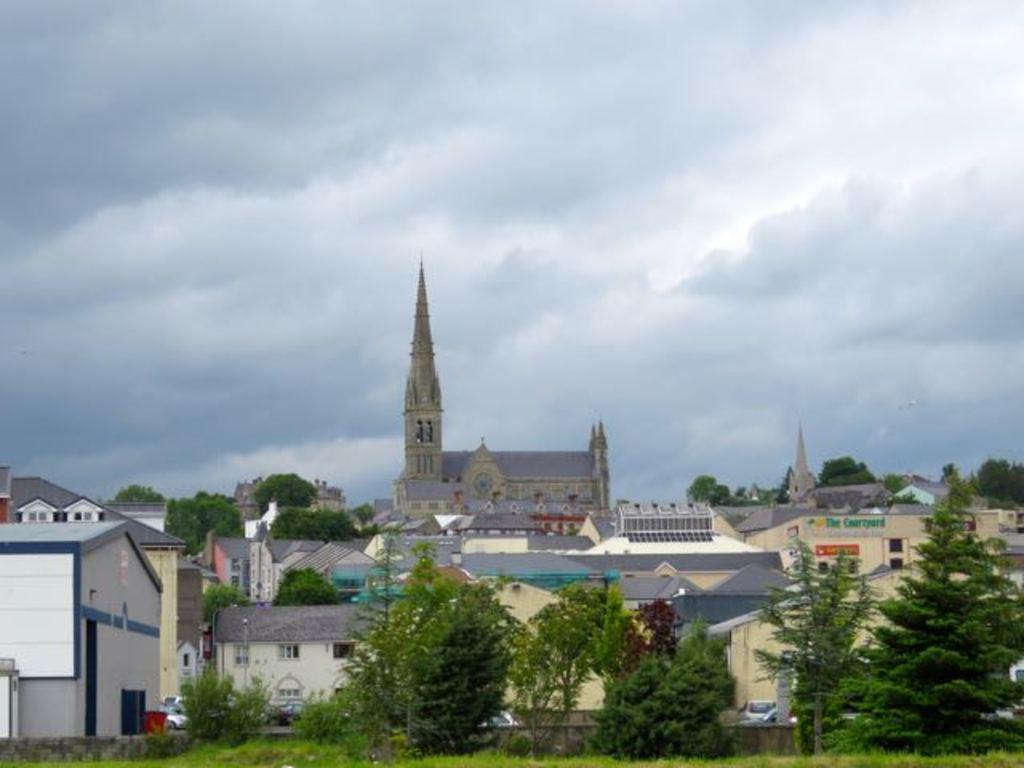What types of structures are visible in the image? There are buildings and houses in the image. What natural elements can be seen in the image? There are trees and plants in the image. What man-made objects are present in the image? There are vehicles in the image. What type of ground surface is visible at the bottom of the image? There is grass at the bottom of the image. What part of the natural environment is visible at the top of the image? The sky is visible at the top of the image. Where is the cup being used during the meeting in the image? There is no cup or meeting present in the image. What type of rail can be seen connecting the buildings in the image? There is no rail connecting the buildings in the image. 